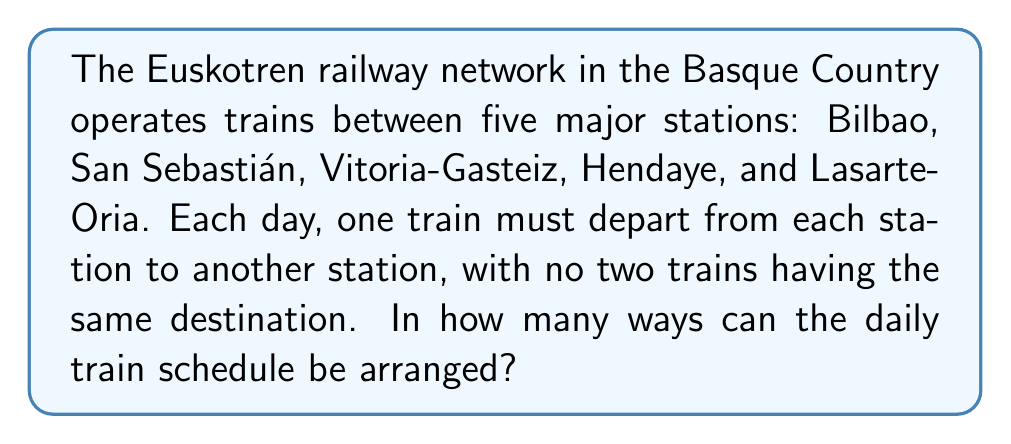What is the answer to this math problem? Let's approach this step-by-step:

1) This problem is a permutation without repetition, as each station must send a train to a different destination.

2) We can think of this as arranging the 5 destination stations in a line, where each position represents the departing station.

3) For the first departing station (let's say Bilbao), we have 4 choices for its destination, as it can't send a train to itself.

4) For the second departing station, we have 3 remaining choices, as it can't send a train to itself or to the destination already chosen by the first station.

5) Continuing this logic, for the third station we have 2 choices, and for the fourth station, only 1 choice remains.

6) The last station has no choice as its train must go to the only remaining destination.

7) This scenario is represented by the permutation formula:

   $$P(5,5) = 5!$$

8) However, we need to divide this by 5, because the last station has no choice:

   $$\frac{5!}{5} = 4!$$

9) Calculating this:

   $$4! = 4 \times 3 \times 2 \times 1 = 24$$

Therefore, there are 24 possible ways to arrange the daily train schedule.
Answer: 24 